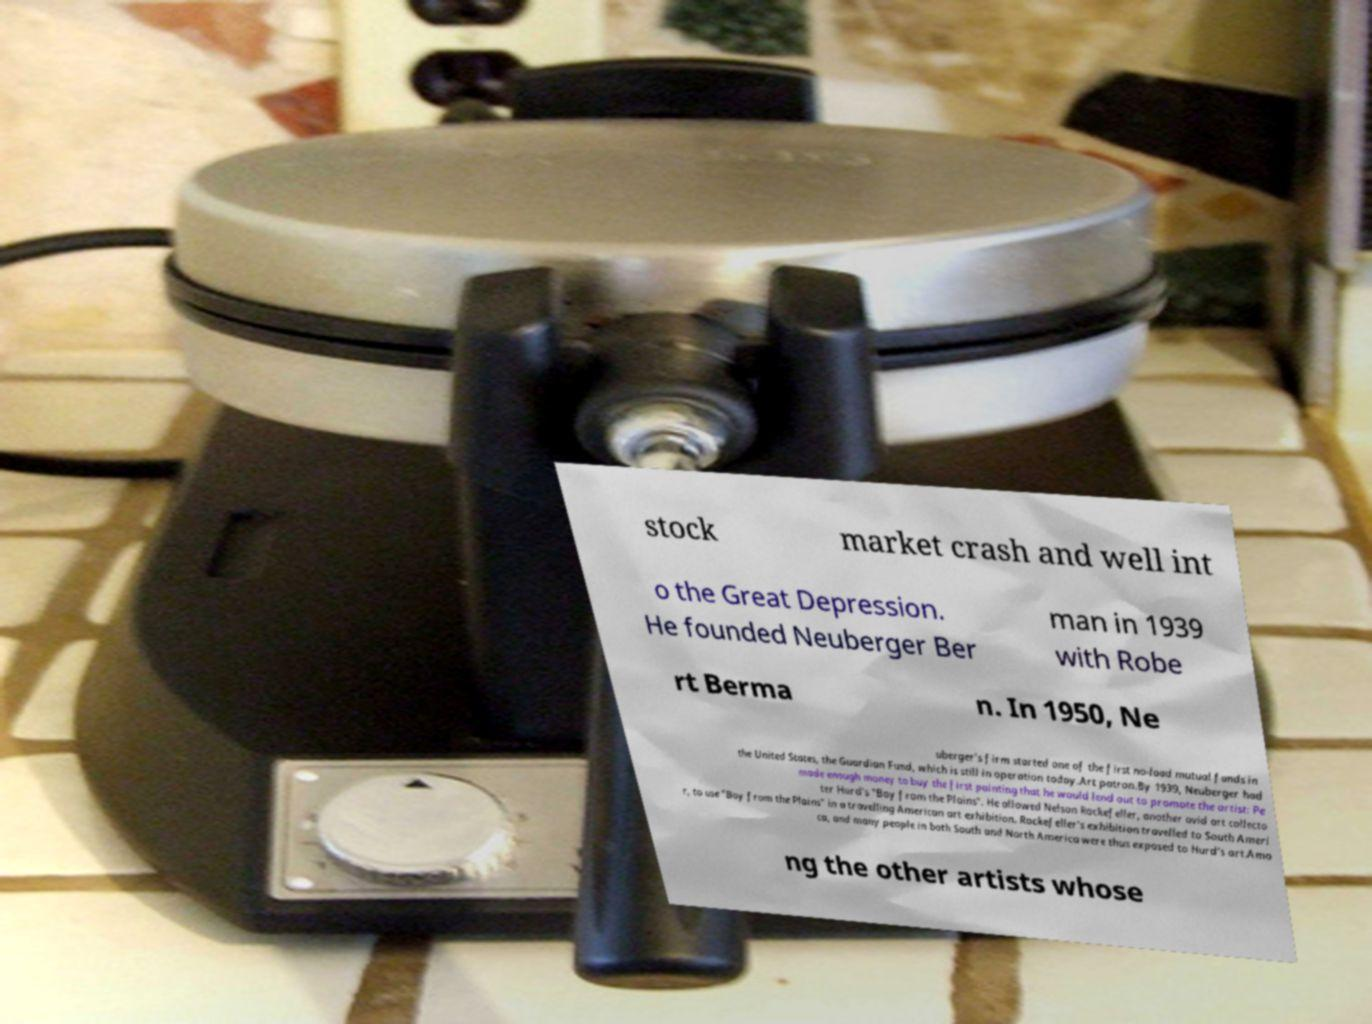There's text embedded in this image that I need extracted. Can you transcribe it verbatim? stock market crash and well int o the Great Depression. He founded Neuberger Ber man in 1939 with Robe rt Berma n. In 1950, Ne uberger's firm started one of the first no-load mutual funds in the United States, the Guardian Fund, which is still in operation today.Art patron.By 1939, Neuberger had made enough money to buy the first painting that he would lend out to promote the artist: Pe ter Hurd's "Boy from the Plains". He allowed Nelson Rockefeller, another avid art collecto r, to use "Boy from the Plains" in a travelling American art exhibition. Rockefeller's exhibition travelled to South Ameri ca, and many people in both South and North America were thus exposed to Hurd's art.Amo ng the other artists whose 